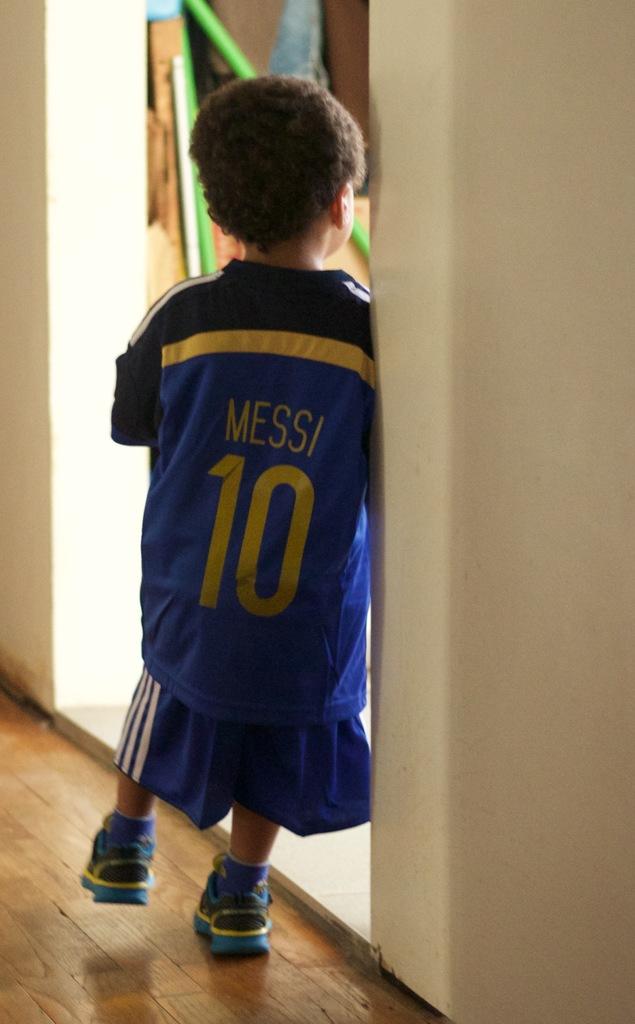What is the player's name on this boy's jersey?
Offer a terse response. Messi. What number is on the pitcher's uniform?
Provide a succinct answer. 10. 